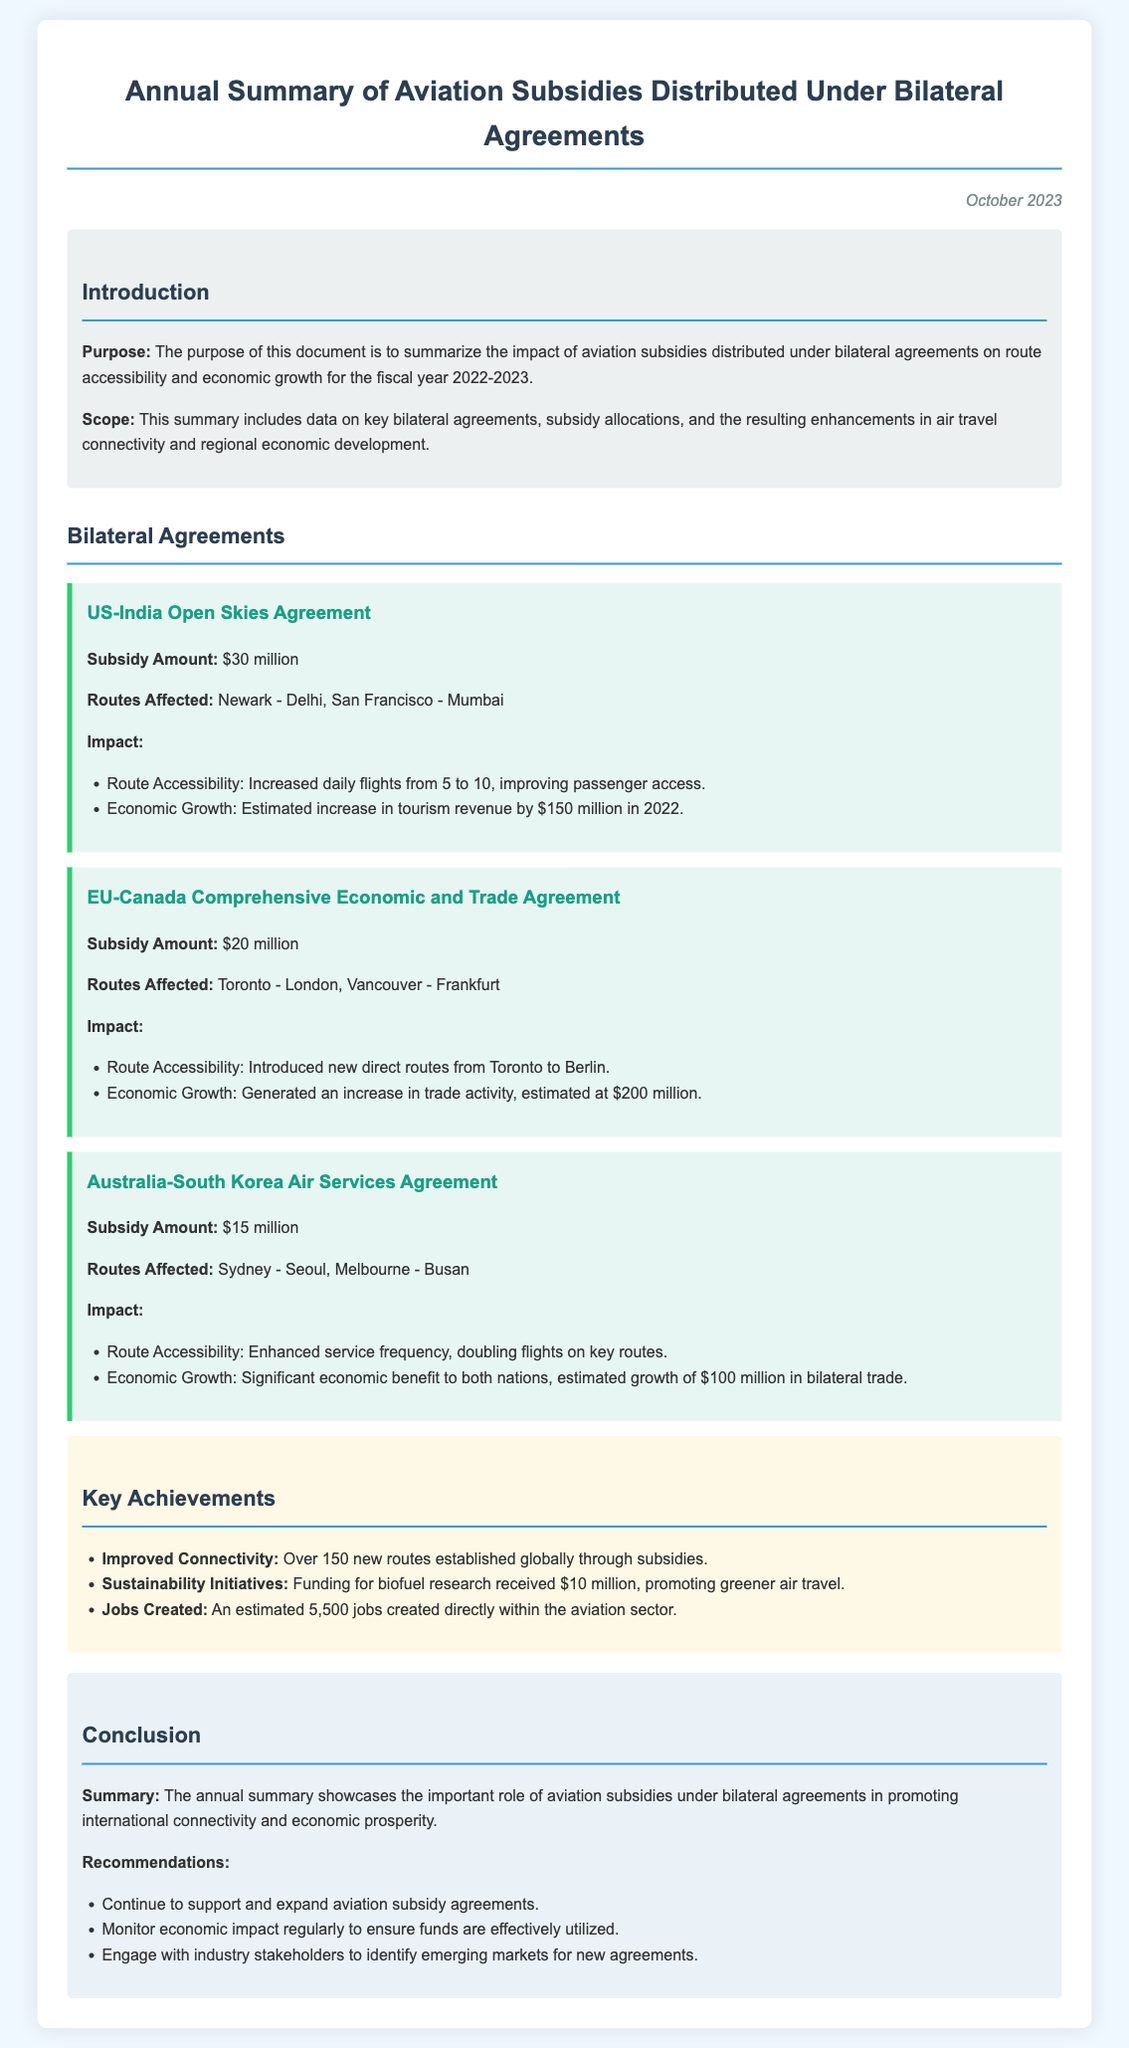What is the total subsidy amount for the US-India Open Skies Agreement? The document states that the subsidy amount for the US-India Open Skies Agreement is $30 million.
Answer: $30 million How many new routes were established globally through subsidies? The document mentions that over 150 new routes were established globally through subsidies.
Answer: Over 150 What was the estimated increase in tourism revenue from the US-India agreement in 2022? The estimated increase in tourism revenue from the US-India agreement in 2022 is stated as $150 million.
Answer: $150 million What routes were affected by the EU-Canada Comprehensive Economic and Trade Agreement? The document lists the routes affected by this agreement as Toronto - London and Vancouver - Frankfurt.
Answer: Toronto - London, Vancouver - Frankfurt How much funding was allocated for biofuel research? The funding for biofuel research received $10 million, as mentioned in the key achievements section.
Answer: $10 million What was the total economic growth estimate for the Australia-South Korea Air Services Agreement? The document indicates a significant economic benefit, estimated growth of $100 million in bilateral trade.
Answer: $100 million What is the main purpose of the annual summary document? The main purpose of the annual summary document is to summarize the impact of aviation subsidies on route accessibility and economic growth.
Answer: To summarize the impact of aviation subsidies on route accessibility and economic growth How many jobs were created in the aviation sector as a result of the subsidies? The document states that an estimated 5,500 jobs were created directly within the aviation sector.
Answer: 5,500 What is one of the recommendations provided in the conclusion section? One recommendation provided is to continue to support and expand aviation subsidy agreements.
Answer: Continue to support and expand aviation subsidy agreements 